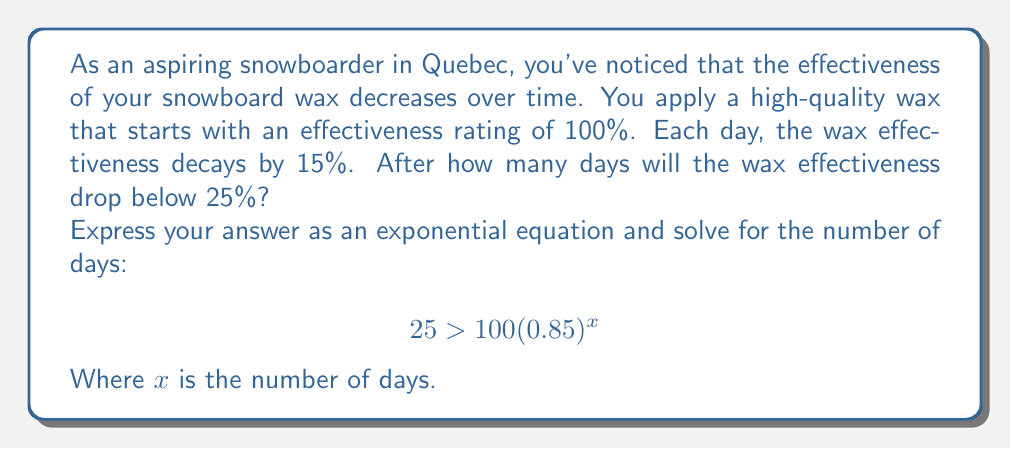Help me with this question. Let's approach this step-by-step:

1) The initial effectiveness is 100%, and it decays by 15% each day. This means that 85% (or 0.85) of the effectiveness remains each day.

2) We can express this as an exponential decay function:
   $$E = 100(0.85)^x$$
   Where $E$ is the effectiveness after $x$ days.

3) We want to find when this drops below 25%, so we set up the inequality:
   $$25 > 100(0.85)^x$$

4) Divide both sides by 100:
   $$0.25 > (0.85)^x$$

5) Take the natural log of both sides:
   $$\ln(0.25) > x \ln(0.85)$$

6) Divide both sides by $\ln(0.85)$ (note that $\ln(0.85)$ is negative, so the inequality sign flips):
   $$\frac{\ln(0.25)}{\ln(0.85)} < x$$

7) Calculate this value:
   $$x > \frac{\ln(0.25)}{\ln(0.85)} \approx 8.97$$

8) Since we're looking for the number of days, which must be a whole number, we round up to the next integer.
Answer: The wax effectiveness will drop below 25% after 9 days. 